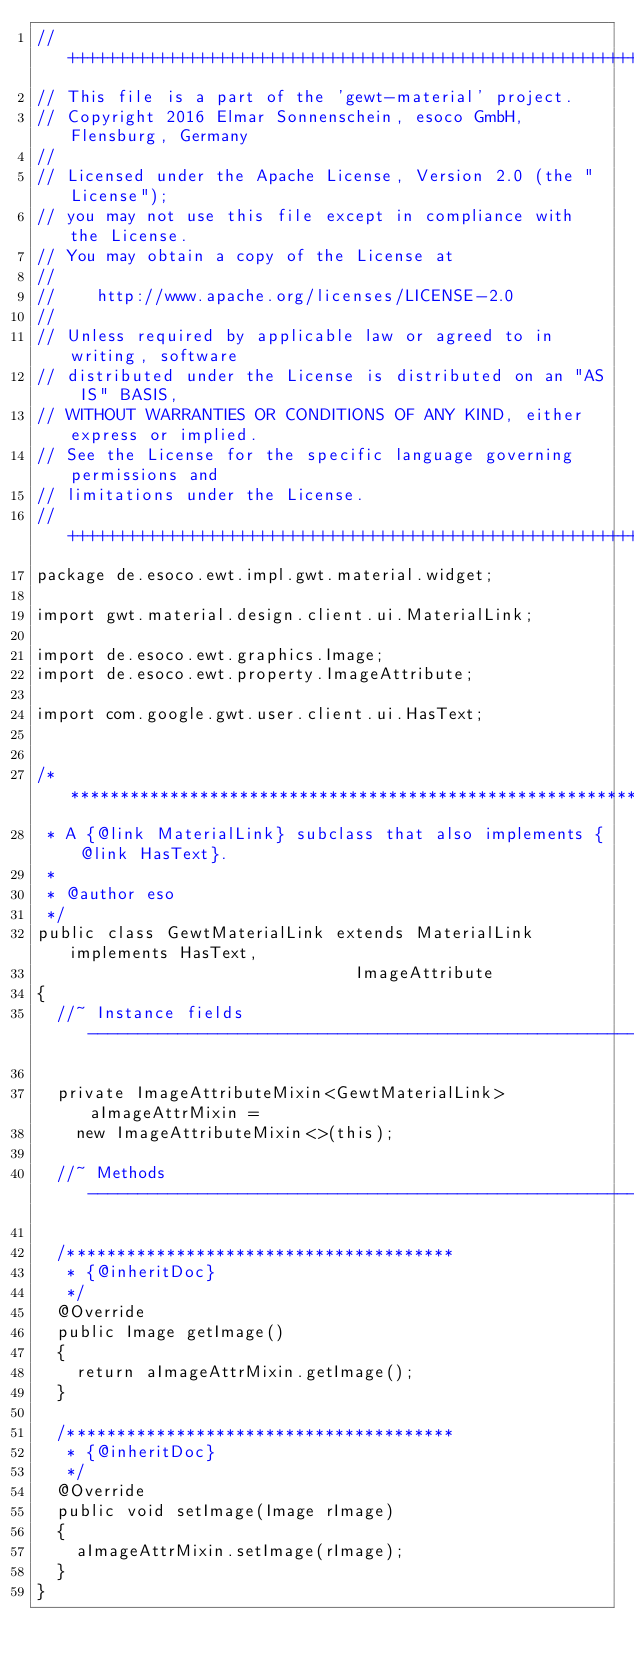<code> <loc_0><loc_0><loc_500><loc_500><_Java_>//++++++++++++++++++++++++++++++++++++++++++++++++++++++++++++++++++++++++++++
// This file is a part of the 'gewt-material' project.
// Copyright 2016 Elmar Sonnenschein, esoco GmbH, Flensburg, Germany
//
// Licensed under the Apache License, Version 2.0 (the "License");
// you may not use this file except in compliance with the License.
// You may obtain a copy of the License at
//
//	  http://www.apache.org/licenses/LICENSE-2.0
//
// Unless required by applicable law or agreed to in writing, software
// distributed under the License is distributed on an "AS IS" BASIS,
// WITHOUT WARRANTIES OR CONDITIONS OF ANY KIND, either express or implied.
// See the License for the specific language governing permissions and
// limitations under the License.
//++++++++++++++++++++++++++++++++++++++++++++++++++++++++++++++++++++++++++++
package de.esoco.ewt.impl.gwt.material.widget;

import gwt.material.design.client.ui.MaterialLink;

import de.esoco.ewt.graphics.Image;
import de.esoco.ewt.property.ImageAttribute;

import com.google.gwt.user.client.ui.HasText;


/********************************************************************
 * A {@link MaterialLink} subclass that also implements {@link HasText}.
 *
 * @author eso
 */
public class GewtMaterialLink extends MaterialLink implements HasText,
															  ImageAttribute
{
	//~ Instance fields --------------------------------------------------------

	private ImageAttributeMixin<GewtMaterialLink> aImageAttrMixin =
		new ImageAttributeMixin<>(this);

	//~ Methods ----------------------------------------------------------------

	/***************************************
	 * {@inheritDoc}
	 */
	@Override
	public Image getImage()
	{
		return aImageAttrMixin.getImage();
	}

	/***************************************
	 * {@inheritDoc}
	 */
	@Override
	public void setImage(Image rImage)
	{
		aImageAttrMixin.setImage(rImage);
	}
}
</code> 